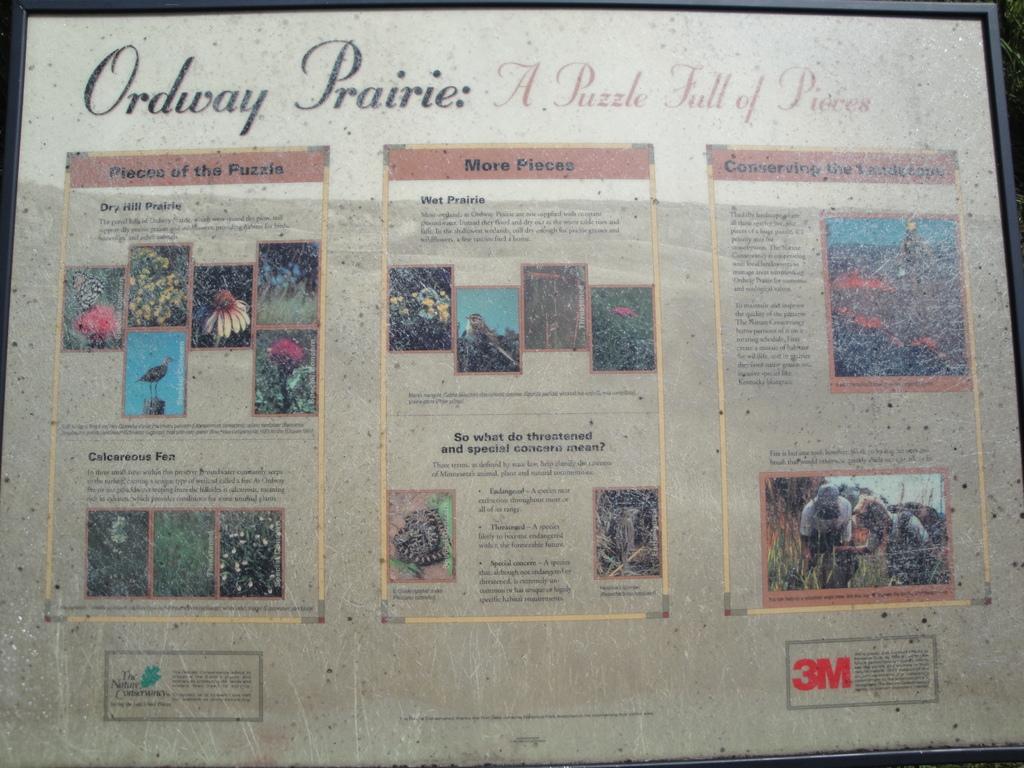What is the puzzle full of?
Your answer should be very brief. Pieces. What is the name of the puzzle?
Make the answer very short. Ordway prairie. 